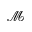Convert formula to latex. <formula><loc_0><loc_0><loc_500><loc_500>\mathcal { M }</formula> 